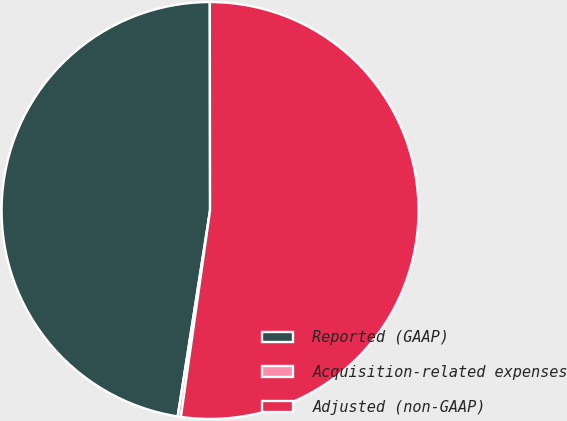Convert chart. <chart><loc_0><loc_0><loc_500><loc_500><pie_chart><fcel>Reported (GAAP)<fcel>Acquisition-related expenses<fcel>Adjusted (non-GAAP)<nl><fcel>47.5%<fcel>0.25%<fcel>52.25%<nl></chart> 